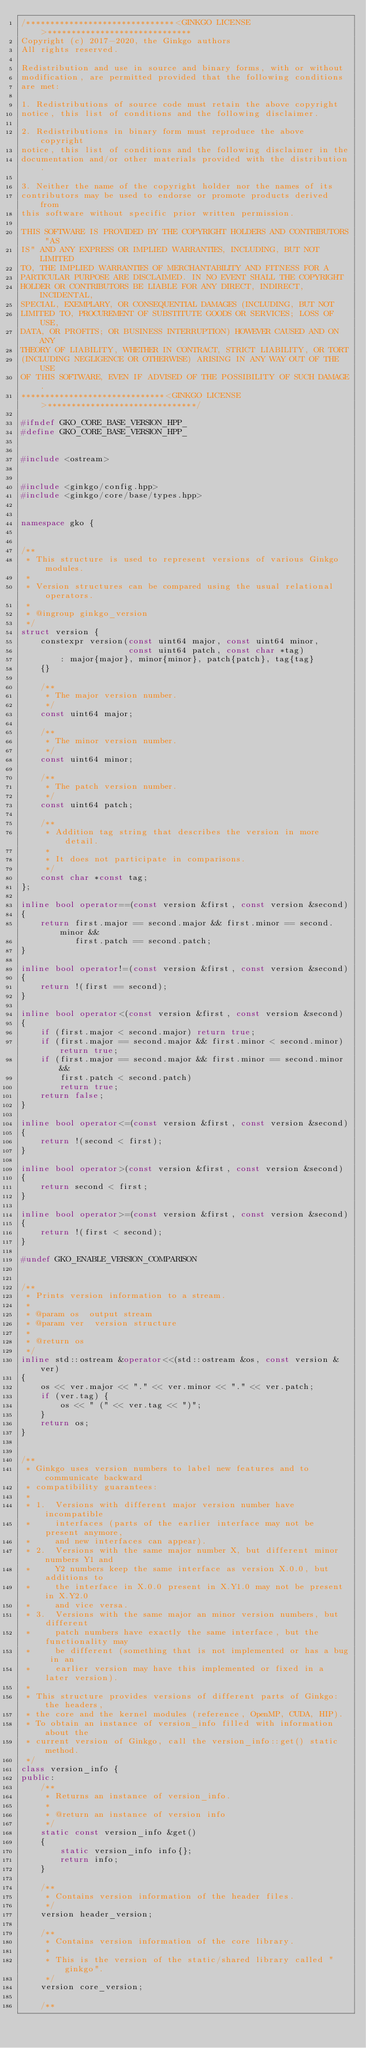Convert code to text. <code><loc_0><loc_0><loc_500><loc_500><_C++_>/*******************************<GINKGO LICENSE>******************************
Copyright (c) 2017-2020, the Ginkgo authors
All rights reserved.

Redistribution and use in source and binary forms, with or without
modification, are permitted provided that the following conditions
are met:

1. Redistributions of source code must retain the above copyright
notice, this list of conditions and the following disclaimer.

2. Redistributions in binary form must reproduce the above copyright
notice, this list of conditions and the following disclaimer in the
documentation and/or other materials provided with the distribution.

3. Neither the name of the copyright holder nor the names of its
contributors may be used to endorse or promote products derived from
this software without specific prior written permission.

THIS SOFTWARE IS PROVIDED BY THE COPYRIGHT HOLDERS AND CONTRIBUTORS "AS
IS" AND ANY EXPRESS OR IMPLIED WARRANTIES, INCLUDING, BUT NOT LIMITED
TO, THE IMPLIED WARRANTIES OF MERCHANTABILITY AND FITNESS FOR A
PARTICULAR PURPOSE ARE DISCLAIMED. IN NO EVENT SHALL THE COPYRIGHT
HOLDER OR CONTRIBUTORS BE LIABLE FOR ANY DIRECT, INDIRECT, INCIDENTAL,
SPECIAL, EXEMPLARY, OR CONSEQUENTIAL DAMAGES (INCLUDING, BUT NOT
LIMITED TO, PROCUREMENT OF SUBSTITUTE GOODS OR SERVICES; LOSS OF USE,
DATA, OR PROFITS; OR BUSINESS INTERRUPTION) HOWEVER CAUSED AND ON ANY
THEORY OF LIABILITY, WHETHER IN CONTRACT, STRICT LIABILITY, OR TORT
(INCLUDING NEGLIGENCE OR OTHERWISE) ARISING IN ANY WAY OUT OF THE USE
OF THIS SOFTWARE, EVEN IF ADVISED OF THE POSSIBILITY OF SUCH DAMAGE.
******************************<GINKGO LICENSE>*******************************/

#ifndef GKO_CORE_BASE_VERSION_HPP_
#define GKO_CORE_BASE_VERSION_HPP_


#include <ostream>


#include <ginkgo/config.hpp>
#include <ginkgo/core/base/types.hpp>


namespace gko {


/**
 * This structure is used to represent versions of various Ginkgo modules.
 *
 * Version structures can be compared using the usual relational operators.
 *
 * @ingroup ginkgo_version
 */
struct version {
    constexpr version(const uint64 major, const uint64 minor,
                      const uint64 patch, const char *tag)
        : major{major}, minor{minor}, patch{patch}, tag{tag}
    {}

    /**
     * The major version number.
     */
    const uint64 major;

    /**
     * The minor version number.
     */
    const uint64 minor;

    /**
     * The patch version number.
     */
    const uint64 patch;

    /**
     * Addition tag string that describes the version in more detail.
     *
     * It does not participate in comparisons.
     */
    const char *const tag;
};

inline bool operator==(const version &first, const version &second)
{
    return first.major == second.major && first.minor == second.minor &&
           first.patch == second.patch;
}

inline bool operator!=(const version &first, const version &second)
{
    return !(first == second);
}

inline bool operator<(const version &first, const version &second)
{
    if (first.major < second.major) return true;
    if (first.major == second.major && first.minor < second.minor) return true;
    if (first.major == second.major && first.minor == second.minor &&
        first.patch < second.patch)
        return true;
    return false;
}

inline bool operator<=(const version &first, const version &second)
{
    return !(second < first);
}

inline bool operator>(const version &first, const version &second)
{
    return second < first;
}

inline bool operator>=(const version &first, const version &second)
{
    return !(first < second);
}

#undef GKO_ENABLE_VERSION_COMPARISON


/**
 * Prints version information to a stream.
 *
 * @param os  output stream
 * @param ver  version structure
 *
 * @return os
 */
inline std::ostream &operator<<(std::ostream &os, const version &ver)
{
    os << ver.major << "." << ver.minor << "." << ver.patch;
    if (ver.tag) {
        os << " (" << ver.tag << ")";
    }
    return os;
}


/**
 * Ginkgo uses version numbers to label new features and to communicate backward
 * compatibility guarantees:
 *
 * 1.  Versions with different major version number have incompatible
 *     interfaces (parts of the earlier interface may not be present anymore,
 *     and new interfaces can appear).
 * 2.  Versions with the same major number X, but different minor numbers Y1 and
 *     Y2 numbers keep the same interface as version X.0.0, but additions to
 *     the interface in X.0.0 present in X.Y1.0 may not be present in X.Y2.0
 *     and vice versa.
 * 3.  Versions with the same major an minor version numbers, but different
 *     patch numbers have exactly the same interface, but the functionality may
 *     be different (something that is not implemented or has a bug in an
 *     earlier version may have this implemented or fixed in a later version).
 *
 * This structure provides versions of different parts of Ginkgo: the headers,
 * the core and the kernel modules (reference, OpenMP, CUDA, HIP).
 * To obtain an instance of version_info filled with information about the
 * current version of Ginkgo, call the version_info::get() static method.
 */
class version_info {
public:
    /**
     * Returns an instance of version_info.
     *
     * @return an instance of version info
     */
    static const version_info &get()
    {
        static version_info info{};
        return info;
    }

    /**
     * Contains version information of the header files.
     */
    version header_version;

    /**
     * Contains version information of the core library.
     *
     * This is the version of the static/shared library called "ginkgo".
     */
    version core_version;

    /**</code> 